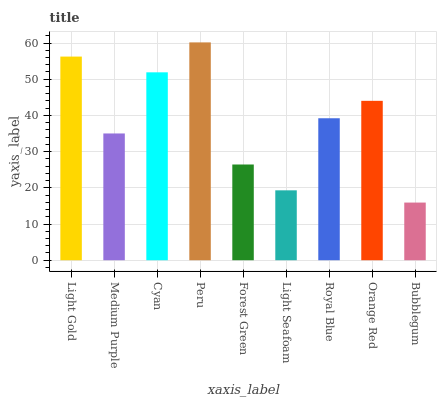Is Bubblegum the minimum?
Answer yes or no. Yes. Is Peru the maximum?
Answer yes or no. Yes. Is Medium Purple the minimum?
Answer yes or no. No. Is Medium Purple the maximum?
Answer yes or no. No. Is Light Gold greater than Medium Purple?
Answer yes or no. Yes. Is Medium Purple less than Light Gold?
Answer yes or no. Yes. Is Medium Purple greater than Light Gold?
Answer yes or no. No. Is Light Gold less than Medium Purple?
Answer yes or no. No. Is Royal Blue the high median?
Answer yes or no. Yes. Is Royal Blue the low median?
Answer yes or no. Yes. Is Light Seafoam the high median?
Answer yes or no. No. Is Medium Purple the low median?
Answer yes or no. No. 